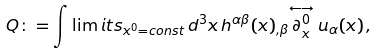Convert formula to latex. <formula><loc_0><loc_0><loc_500><loc_500>Q \colon = \int \lim i t s _ { x ^ { 0 } = c o n s t } \, d ^ { 3 } x \, h ^ { \alpha \beta } ( x ) _ { , \beta } { \stackrel { \longleftrightarrow } { \partial _ { x } ^ { 0 } } u _ { \alpha } ( x ) } \, ,</formula> 